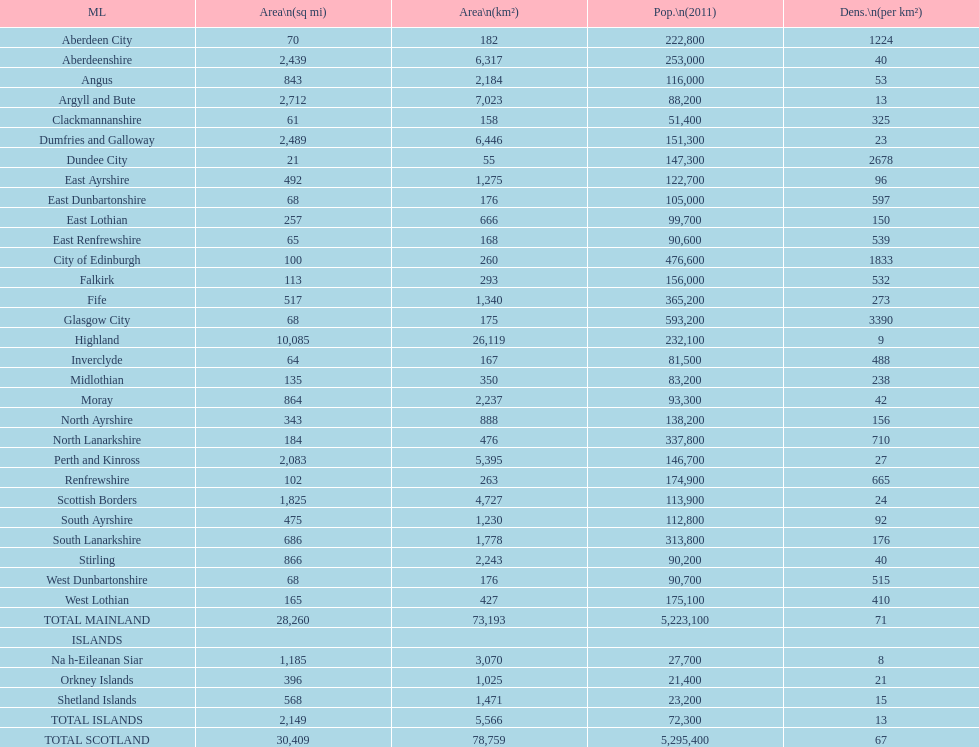Which is the only subdivision to have a greater area than argyll and bute? Highland. 